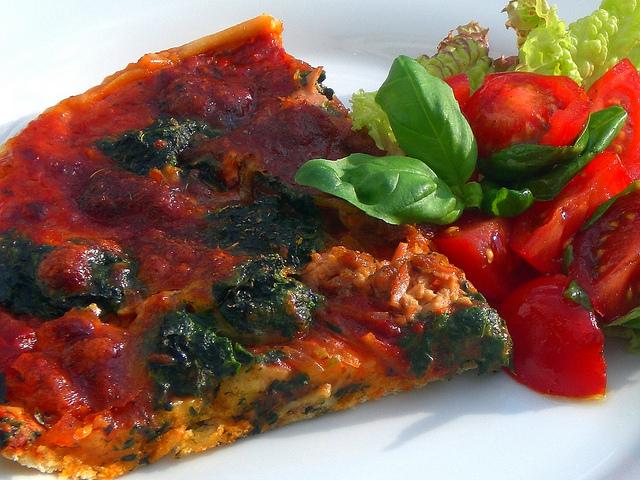What kind of seed creates the red item?
Concise answer only. Tomato. The red things on the right are vegetables?
Keep it brief. Yes. What is on the pizza?
Keep it brief. Spinach. 